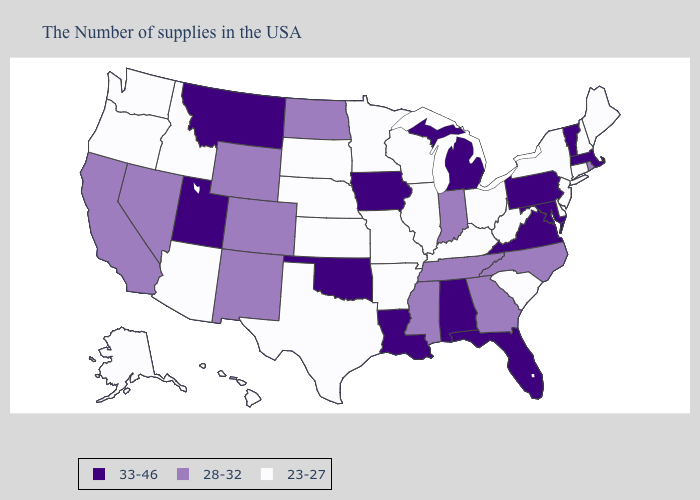What is the highest value in the USA?
Short answer required. 33-46. What is the highest value in states that border Wisconsin?
Write a very short answer. 33-46. What is the highest value in the USA?
Give a very brief answer. 33-46. Does Nevada have the lowest value in the West?
Give a very brief answer. No. Does West Virginia have the lowest value in the South?
Quick response, please. Yes. What is the value of Louisiana?
Concise answer only. 33-46. Is the legend a continuous bar?
Answer briefly. No. Among the states that border Idaho , which have the highest value?
Concise answer only. Utah, Montana. Among the states that border New Jersey , does New York have the lowest value?
Quick response, please. Yes. What is the highest value in the USA?
Be succinct. 33-46. Name the states that have a value in the range 33-46?
Write a very short answer. Massachusetts, Vermont, Maryland, Pennsylvania, Virginia, Florida, Michigan, Alabama, Louisiana, Iowa, Oklahoma, Utah, Montana. What is the value of New York?
Be succinct. 23-27. Name the states that have a value in the range 23-27?
Answer briefly. Maine, New Hampshire, Connecticut, New York, New Jersey, Delaware, South Carolina, West Virginia, Ohio, Kentucky, Wisconsin, Illinois, Missouri, Arkansas, Minnesota, Kansas, Nebraska, Texas, South Dakota, Arizona, Idaho, Washington, Oregon, Alaska, Hawaii. What is the value of Wisconsin?
Concise answer only. 23-27. Does the map have missing data?
Give a very brief answer. No. 